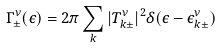Convert formula to latex. <formula><loc_0><loc_0><loc_500><loc_500>\Gamma ^ { \nu } _ { \pm } ( \epsilon ) = 2 \pi \sum _ { k } | T _ { k \pm } ^ { \nu } | ^ { 2 } \delta ( \epsilon - \epsilon _ { k \pm } ^ { \nu } )</formula> 